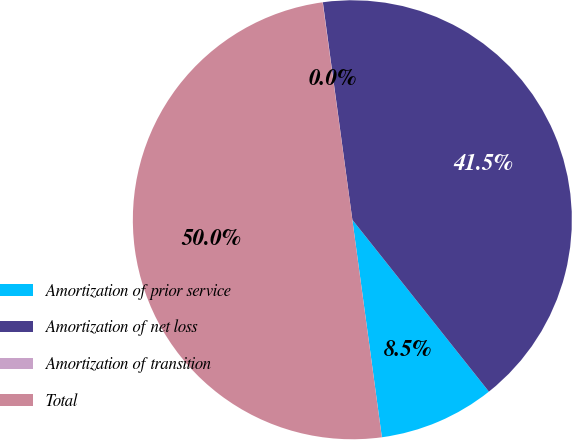Convert chart to OTSL. <chart><loc_0><loc_0><loc_500><loc_500><pie_chart><fcel>Amortization of prior service<fcel>Amortization of net loss<fcel>Amortization of transition<fcel>Total<nl><fcel>8.54%<fcel>41.46%<fcel>0.02%<fcel>49.98%<nl></chart> 